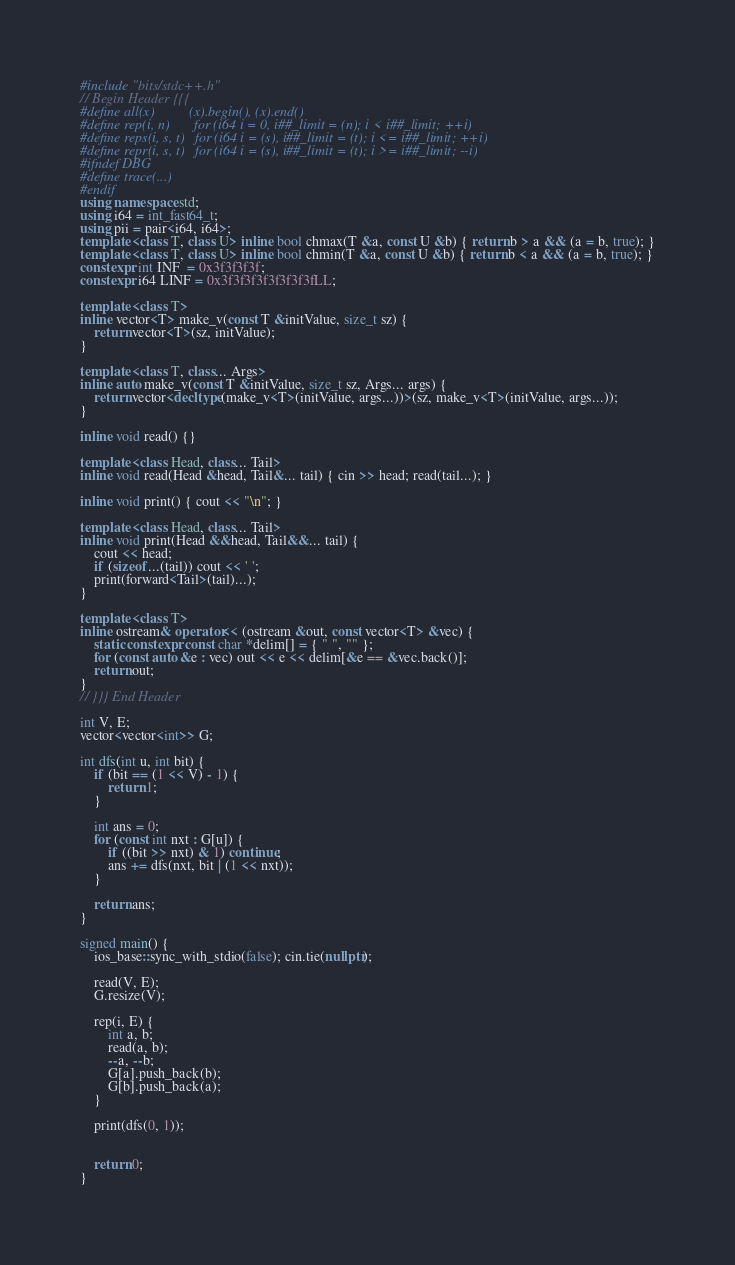Convert code to text. <code><loc_0><loc_0><loc_500><loc_500><_C++_>#include "bits/stdc++.h"
// Begin Header {{{
#define all(x)          (x).begin(), (x).end()
#define rep(i, n)       for (i64 i = 0, i##_limit = (n); i < i##_limit; ++i)
#define reps(i, s, t)   for (i64 i = (s), i##_limit = (t); i <= i##_limit; ++i)
#define repr(i, s, t)   for (i64 i = (s), i##_limit = (t); i >= i##_limit; --i)
#ifndef DBG
#define trace(...)
#endif
using namespace std;
using i64 = int_fast64_t;
using pii = pair<i64, i64>;
template <class T, class U> inline bool chmax(T &a, const U &b) { return b > a && (a = b, true); }
template <class T, class U> inline bool chmin(T &a, const U &b) { return b < a && (a = b, true); }
constexpr int INF  = 0x3f3f3f3f;
constexpr i64 LINF = 0x3f3f3f3f3f3f3f3fLL;

template <class T>
inline vector<T> make_v(const T &initValue, size_t sz) {
    return vector<T>(sz, initValue);
}

template <class T, class... Args>
inline auto make_v(const T &initValue, size_t sz, Args... args) {
    return vector<decltype(make_v<T>(initValue, args...))>(sz, make_v<T>(initValue, args...));
}

inline void read() {}

template <class Head, class... Tail>
inline void read(Head &head, Tail&... tail) { cin >> head; read(tail...); }

inline void print() { cout << "\n"; }

template <class Head, class... Tail>
inline void print(Head &&head, Tail&&... tail) {
    cout << head;
    if (sizeof...(tail)) cout << ' ';
    print(forward<Tail>(tail)...);
}

template <class T>
inline ostream& operator<< (ostream &out, const vector<T> &vec) {
    static constexpr const char *delim[] = { " ", "" };
    for (const auto &e : vec) out << e << delim[&e == &vec.back()];
    return out;
}
// }}} End Header

int V, E;
vector<vector<int>> G;

int dfs(int u, int bit) {
    if (bit == (1 << V) - 1) {
        return 1;
    }

    int ans = 0;
    for (const int nxt : G[u]) {
        if ((bit >> nxt) & 1) continue;
        ans += dfs(nxt, bit | (1 << nxt));
    }

    return ans;
}

signed main() {
    ios_base::sync_with_stdio(false); cin.tie(nullptr);

    read(V, E);
    G.resize(V);

    rep(i, E) {
        int a, b;
        read(a, b);
        --a, --b;
        G[a].push_back(b);
        G[b].push_back(a);
    }

    print(dfs(0, 1));


    return 0;
}
</code> 